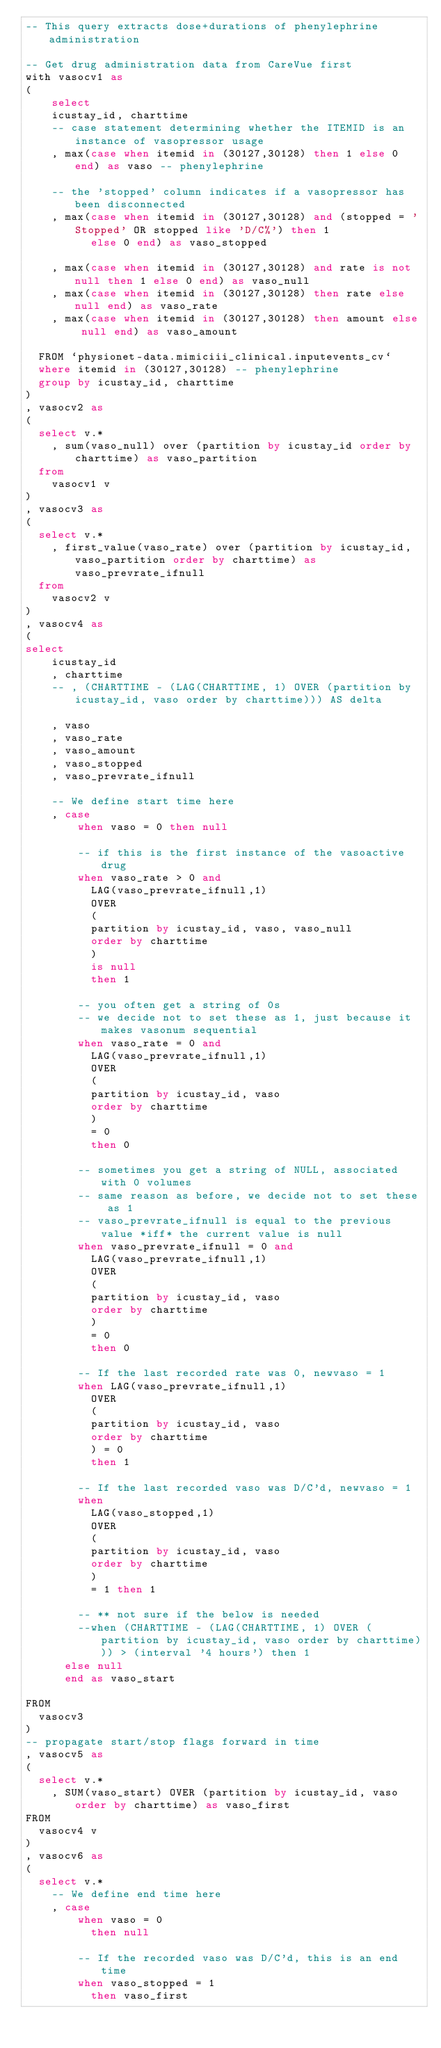Convert code to text. <code><loc_0><loc_0><loc_500><loc_500><_SQL_>-- This query extracts dose+durations of phenylephrine administration

-- Get drug administration data from CareVue first
with vasocv1 as
(
    select
    icustay_id, charttime
    -- case statement determining whether the ITEMID is an instance of vasopressor usage
    , max(case when itemid in (30127,30128) then 1 else 0 end) as vaso -- phenylephrine

    -- the 'stopped' column indicates if a vasopressor has been disconnected
    , max(case when itemid in (30127,30128) and (stopped = 'Stopped' OR stopped like 'D/C%') then 1
          else 0 end) as vaso_stopped

    , max(case when itemid in (30127,30128) and rate is not null then 1 else 0 end) as vaso_null
    , max(case when itemid in (30127,30128) then rate else null end) as vaso_rate
    , max(case when itemid in (30127,30128) then amount else null end) as vaso_amount

  FROM `physionet-data.mimiciii_clinical.inputevents_cv`
  where itemid in (30127,30128) -- phenylephrine
  group by icustay_id, charttime
)
, vasocv2 as
(
  select v.*
    , sum(vaso_null) over (partition by icustay_id order by charttime) as vaso_partition
  from
    vasocv1 v
)
, vasocv3 as
(
  select v.*
    , first_value(vaso_rate) over (partition by icustay_id, vaso_partition order by charttime) as vaso_prevrate_ifnull
  from
    vasocv2 v
)
, vasocv4 as
(
select
    icustay_id
    , charttime
    -- , (CHARTTIME - (LAG(CHARTTIME, 1) OVER (partition by icustay_id, vaso order by charttime))) AS delta

    , vaso
    , vaso_rate
    , vaso_amount
    , vaso_stopped
    , vaso_prevrate_ifnull

    -- We define start time here
    , case
        when vaso = 0 then null

        -- if this is the first instance of the vasoactive drug
        when vaso_rate > 0 and
          LAG(vaso_prevrate_ifnull,1)
          OVER
          (
          partition by icustay_id, vaso, vaso_null
          order by charttime
          )
          is null
          then 1

        -- you often get a string of 0s
        -- we decide not to set these as 1, just because it makes vasonum sequential
        when vaso_rate = 0 and
          LAG(vaso_prevrate_ifnull,1)
          OVER
          (
          partition by icustay_id, vaso
          order by charttime
          )
          = 0
          then 0

        -- sometimes you get a string of NULL, associated with 0 volumes
        -- same reason as before, we decide not to set these as 1
        -- vaso_prevrate_ifnull is equal to the previous value *iff* the current value is null
        when vaso_prevrate_ifnull = 0 and
          LAG(vaso_prevrate_ifnull,1)
          OVER
          (
          partition by icustay_id, vaso
          order by charttime
          )
          = 0
          then 0

        -- If the last recorded rate was 0, newvaso = 1
        when LAG(vaso_prevrate_ifnull,1)
          OVER
          (
          partition by icustay_id, vaso
          order by charttime
          ) = 0
          then 1

        -- If the last recorded vaso was D/C'd, newvaso = 1
        when
          LAG(vaso_stopped,1)
          OVER
          (
          partition by icustay_id, vaso
          order by charttime
          )
          = 1 then 1

        -- ** not sure if the below is needed
        --when (CHARTTIME - (LAG(CHARTTIME, 1) OVER (partition by icustay_id, vaso order by charttime))) > (interval '4 hours') then 1
      else null
      end as vaso_start

FROM
  vasocv3
)
-- propagate start/stop flags forward in time
, vasocv5 as
(
  select v.*
    , SUM(vaso_start) OVER (partition by icustay_id, vaso order by charttime) as vaso_first
FROM
  vasocv4 v
)
, vasocv6 as
(
  select v.*
    -- We define end time here
    , case
        when vaso = 0
          then null

        -- If the recorded vaso was D/C'd, this is an end time
        when vaso_stopped = 1
          then vaso_first
</code> 